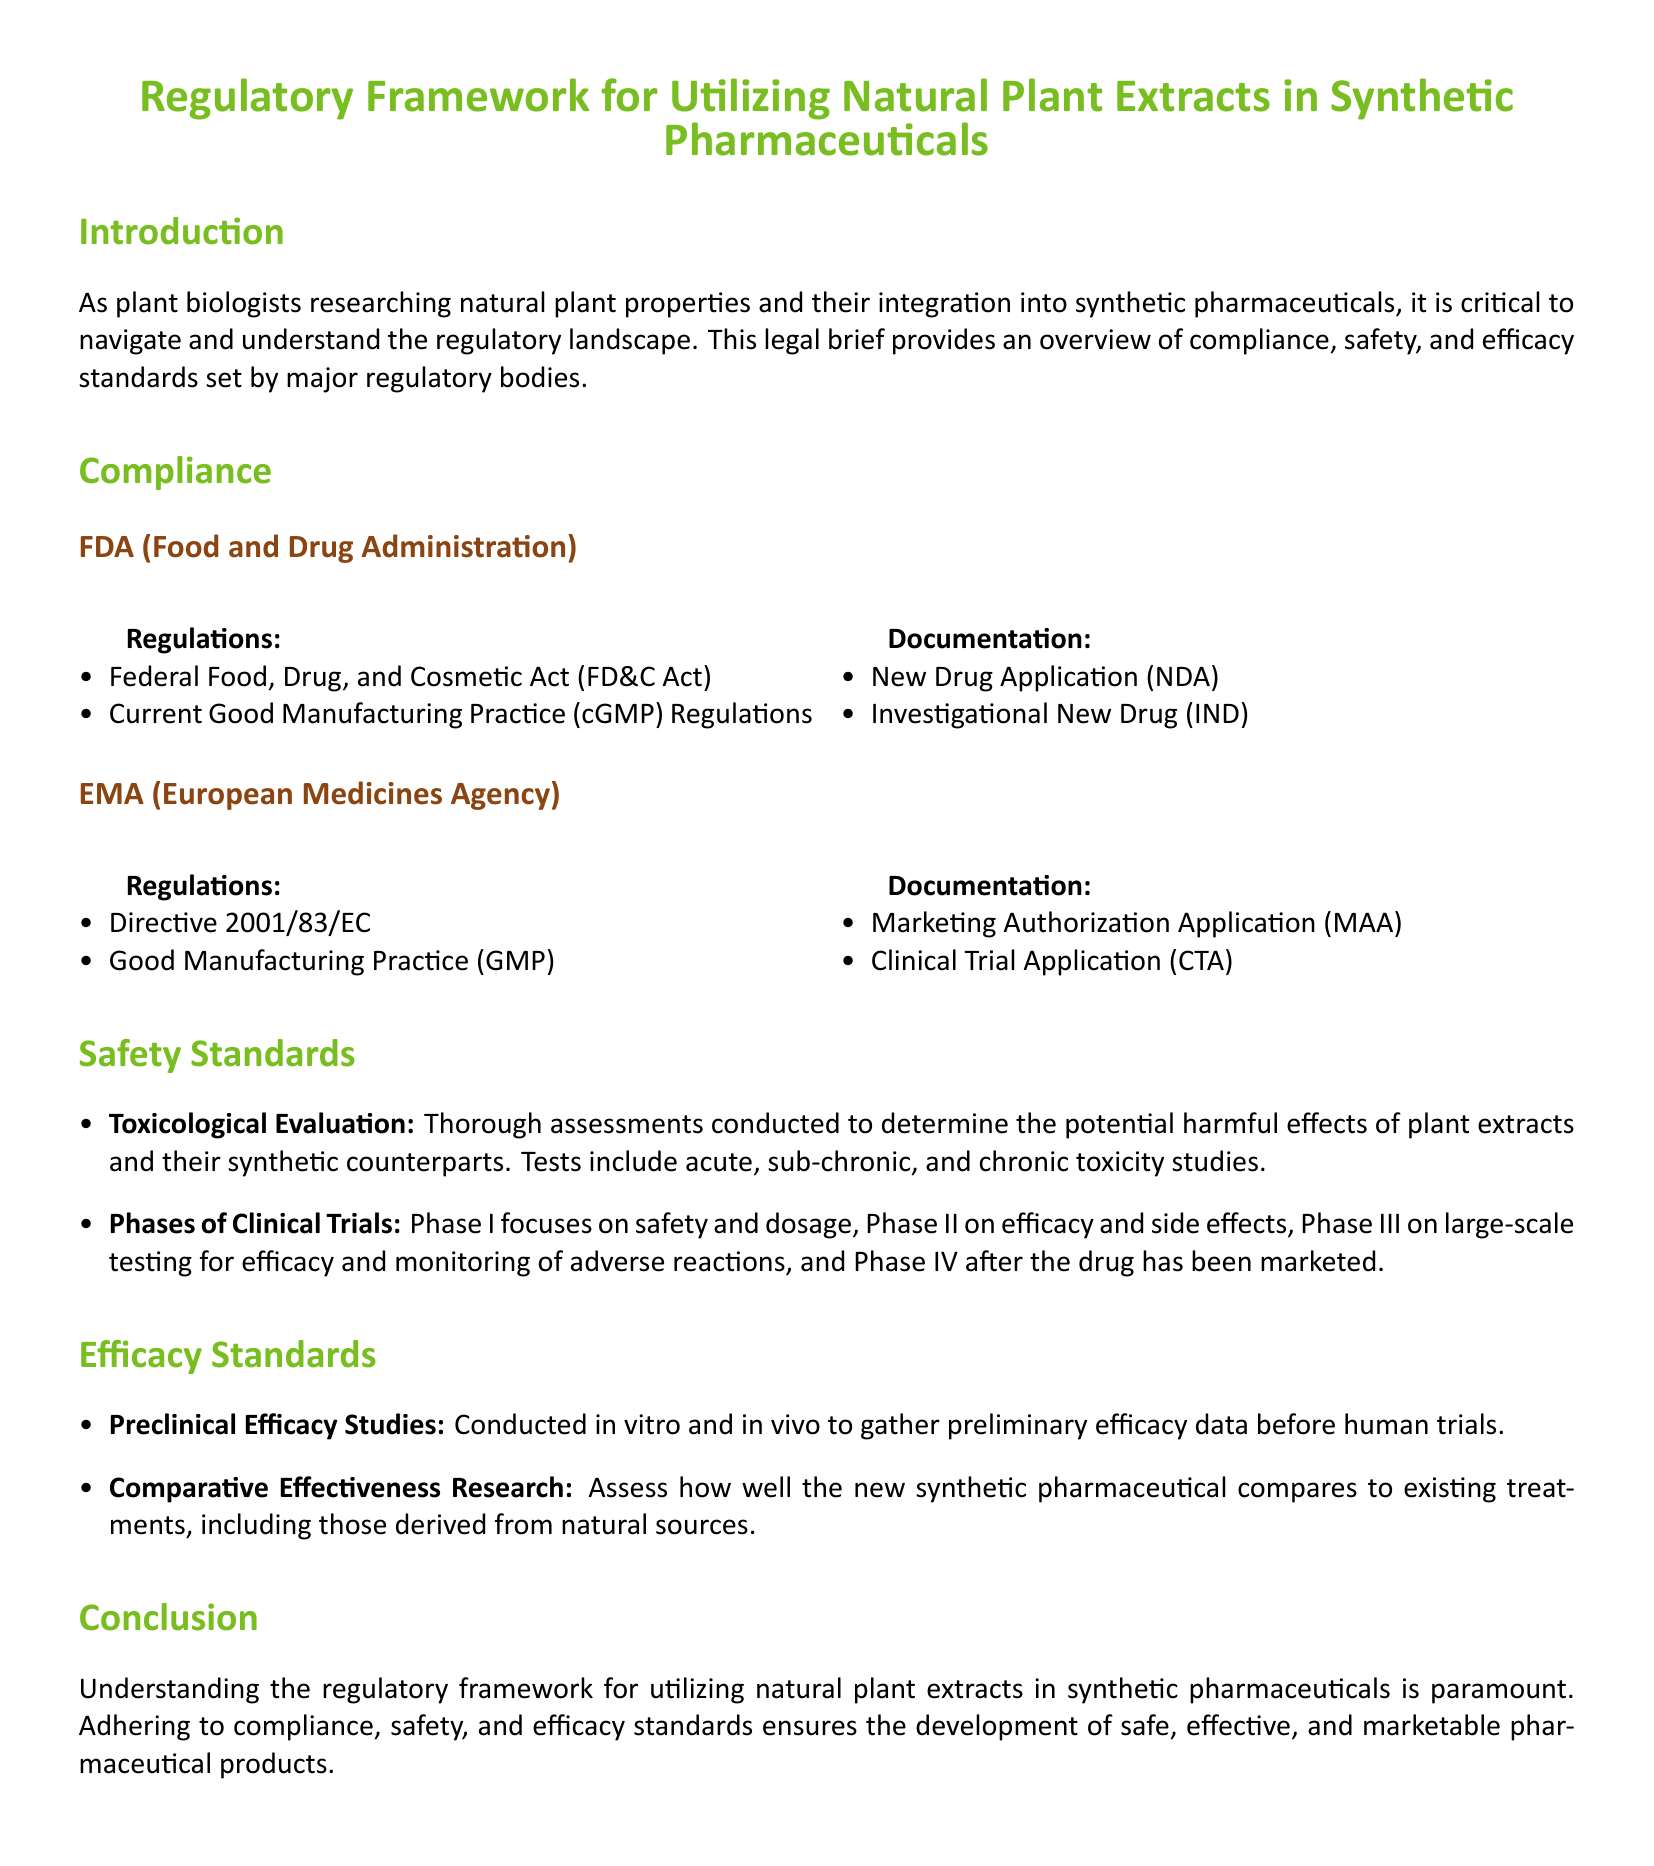What are the key regulations outlined by the FDA? The key regulations are the Federal Food, Drug, and Cosmetic Act and Current Good Manufacturing Practice Regulations.
Answer: Federal Food, Drug, and Cosmetic Act; Current Good Manufacturing Practice Regulations What is required documentation for the FDA compliance? Required documentation includes the New Drug Application and the Investigational New Drug.
Answer: New Drug Application; Investigational New Drug What does the EMA regulation directive number refer to? The directive number refers to Directive 2001/83/EC.
Answer: Directive 2001/83/EC What are the phases of clinical trials mentioned? The phases mentioned are Phase I, Phase II, Phase III, and Phase IV.
Answer: Phase I, Phase II, Phase III, Phase IV What type of studies are conducted for toxicological evaluation? They include acute, sub-chronic, and chronic toxicity studies.
Answer: Acute, sub-chronic, and chronic toxicity studies What is the purpose of comparative effectiveness research? It assesses how well the new synthetic pharmaceutical compares to existing treatments.
Answer: Assess comparison to existing treatments What is the main focus of Phase I clinical trials? The main focus is on safety and dosage.
Answer: Safety and dosage What pharmaceutical documentation does the EMA require for clinical trials? The EMA requires a Clinical Trial Application.
Answer: Clinical Trial Application What should preclinical efficacy studies gather data on? They should gather preliminary efficacy data before human trials.
Answer: Preliminary efficacy data before human trials 